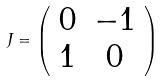Convert formula to latex. <formula><loc_0><loc_0><loc_500><loc_500>\ J = \left ( \begin{array} { c c } 0 & - 1 \\ 1 & 0 \end{array} \right )</formula> 